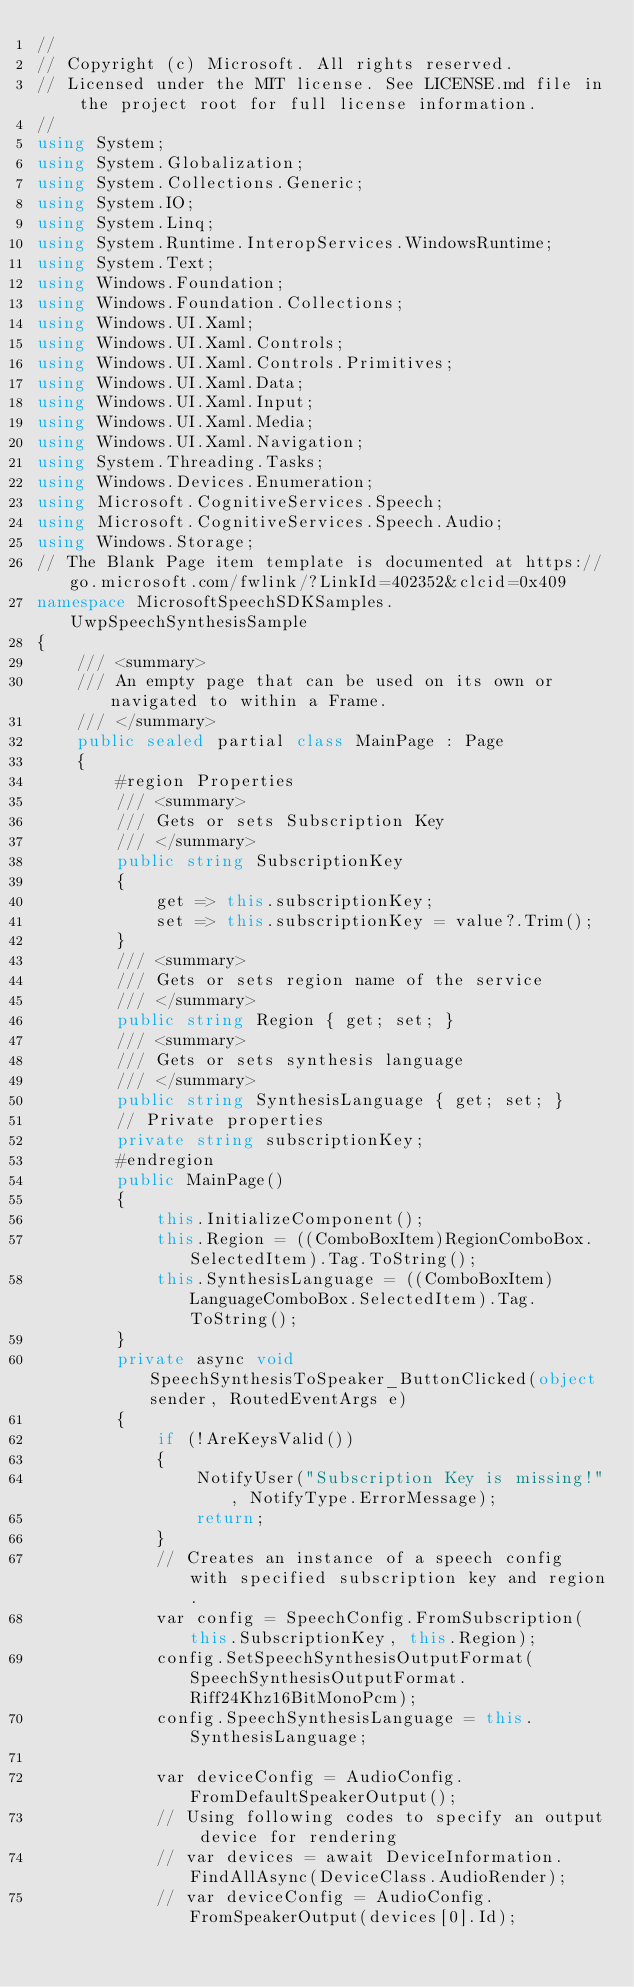<code> <loc_0><loc_0><loc_500><loc_500><_C#_>//
// Copyright (c) Microsoft. All rights reserved.
// Licensed under the MIT license. See LICENSE.md file in the project root for full license information.
//
using System;
using System.Globalization;
using System.Collections.Generic;
using System.IO;
using System.Linq;
using System.Runtime.InteropServices.WindowsRuntime;
using System.Text;
using Windows.Foundation;
using Windows.Foundation.Collections;
using Windows.UI.Xaml;
using Windows.UI.Xaml.Controls;
using Windows.UI.Xaml.Controls.Primitives;
using Windows.UI.Xaml.Data;
using Windows.UI.Xaml.Input;
using Windows.UI.Xaml.Media;
using Windows.UI.Xaml.Navigation;
using System.Threading.Tasks;
using Windows.Devices.Enumeration;
using Microsoft.CognitiveServices.Speech;
using Microsoft.CognitiveServices.Speech.Audio;
using Windows.Storage;
// The Blank Page item template is documented at https://go.microsoft.com/fwlink/?LinkId=402352&clcid=0x409
namespace MicrosoftSpeechSDKSamples.UwpSpeechSynthesisSample
{
    /// <summary>
    /// An empty page that can be used on its own or navigated to within a Frame.
    /// </summary>
    public sealed partial class MainPage : Page
    {
        #region Properties
        /// <summary>
        /// Gets or sets Subscription Key
        /// </summary>
        public string SubscriptionKey
        {
            get => this.subscriptionKey;
            set => this.subscriptionKey = value?.Trim();
        }
        /// <summary>
        /// Gets or sets region name of the service
        /// </summary>
        public string Region { get; set; }
        /// <summary>
        /// Gets or sets synthesis language
        /// </summary>
        public string SynthesisLanguage { get; set; }
        // Private properties
        private string subscriptionKey;
        #endregion
        public MainPage()
        {
            this.InitializeComponent();
            this.Region = ((ComboBoxItem)RegionComboBox.SelectedItem).Tag.ToString();
            this.SynthesisLanguage = ((ComboBoxItem)LanguageComboBox.SelectedItem).Tag.ToString();
        }
        private async void SpeechSynthesisToSpeaker_ButtonClicked(object sender, RoutedEventArgs e)
        {
            if (!AreKeysValid())
            {
                NotifyUser("Subscription Key is missing!", NotifyType.ErrorMessage);
                return;
            }
            // Creates an instance of a speech config with specified subscription key and region.
            var config = SpeechConfig.FromSubscription(this.SubscriptionKey, this.Region);
            config.SetSpeechSynthesisOutputFormat(SpeechSynthesisOutputFormat.Riff24Khz16BitMonoPcm);
            config.SpeechSynthesisLanguage = this.SynthesisLanguage;

            var deviceConfig = AudioConfig.FromDefaultSpeakerOutput();
            // Using following codes to specify an output device for rendering 
            // var devices = await DeviceInformation.FindAllAsync(DeviceClass.AudioRender);
            // var deviceConfig = AudioConfig.FromSpeakerOutput(devices[0].Id);
</code> 